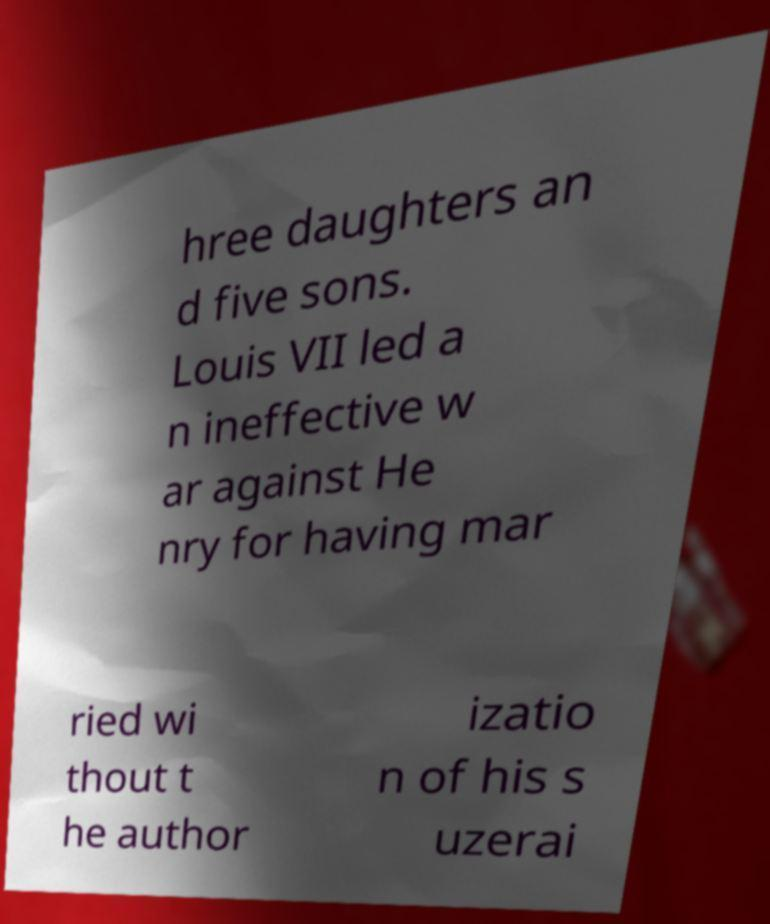Could you assist in decoding the text presented in this image and type it out clearly? hree daughters an d five sons. Louis VII led a n ineffective w ar against He nry for having mar ried wi thout t he author izatio n of his s uzerai 